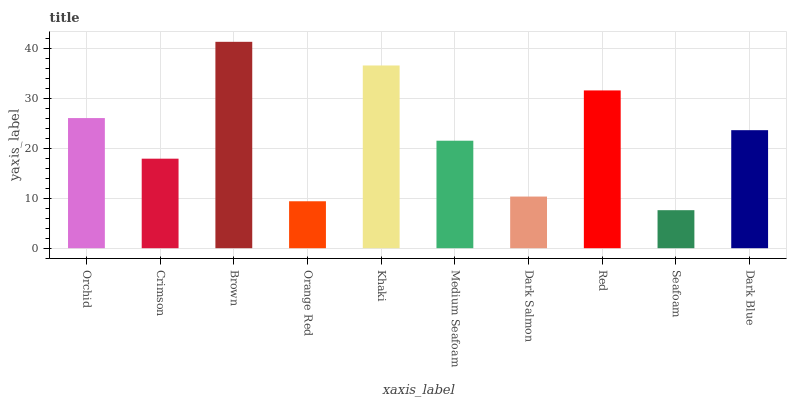Is Seafoam the minimum?
Answer yes or no. Yes. Is Brown the maximum?
Answer yes or no. Yes. Is Crimson the minimum?
Answer yes or no. No. Is Crimson the maximum?
Answer yes or no. No. Is Orchid greater than Crimson?
Answer yes or no. Yes. Is Crimson less than Orchid?
Answer yes or no. Yes. Is Crimson greater than Orchid?
Answer yes or no. No. Is Orchid less than Crimson?
Answer yes or no. No. Is Dark Blue the high median?
Answer yes or no. Yes. Is Medium Seafoam the low median?
Answer yes or no. Yes. Is Orchid the high median?
Answer yes or no. No. Is Orange Red the low median?
Answer yes or no. No. 